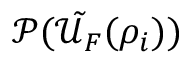<formula> <loc_0><loc_0><loc_500><loc_500>\mathcal { P } ( \tilde { \mathcal { U } _ { F } } ( \rho _ { i } ) )</formula> 